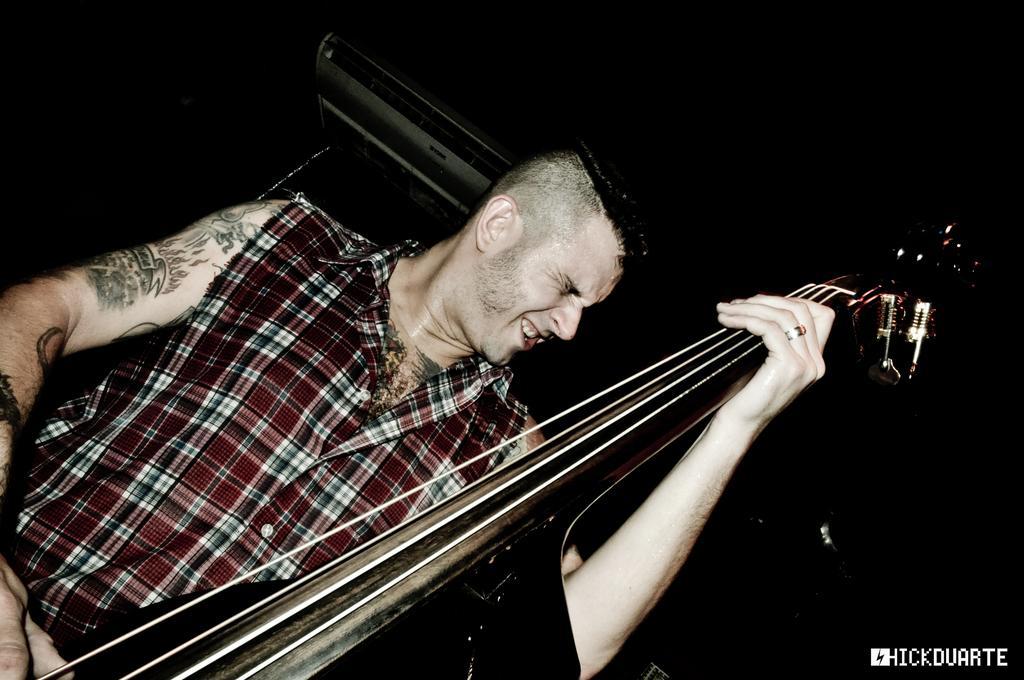Please provide a concise description of this image. In this image I can see the person with the dress and holding the musical instrument. And there is a black background. 